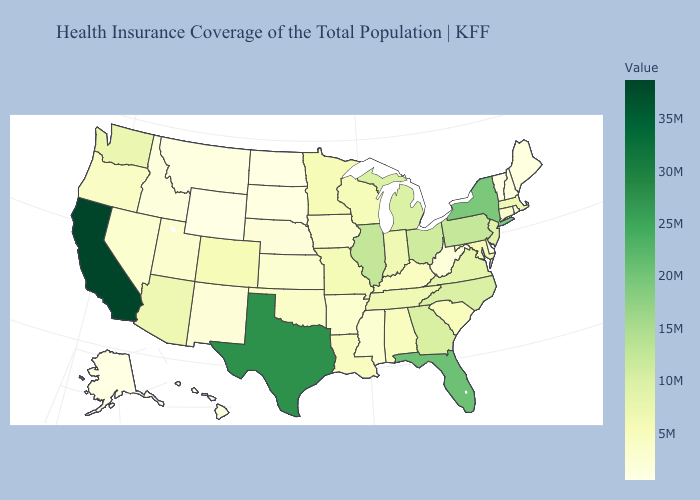Which states have the highest value in the USA?
Keep it brief. California. Among the states that border Georgia , which have the lowest value?
Short answer required. Alabama. Does New York have the highest value in the Northeast?
Be succinct. Yes. Does Kentucky have a lower value than Georgia?
Keep it brief. Yes. Which states have the lowest value in the South?
Concise answer only. Delaware. Which states have the lowest value in the Northeast?
Write a very short answer. Vermont. 